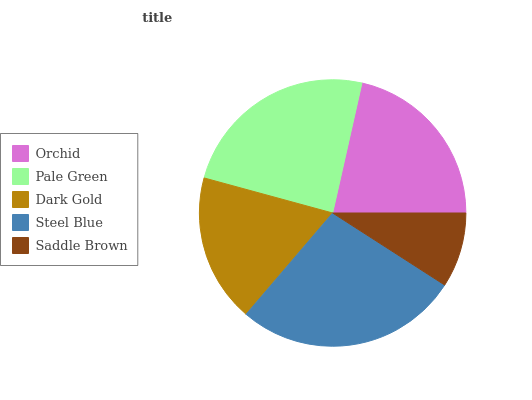Is Saddle Brown the minimum?
Answer yes or no. Yes. Is Steel Blue the maximum?
Answer yes or no. Yes. Is Pale Green the minimum?
Answer yes or no. No. Is Pale Green the maximum?
Answer yes or no. No. Is Pale Green greater than Orchid?
Answer yes or no. Yes. Is Orchid less than Pale Green?
Answer yes or no. Yes. Is Orchid greater than Pale Green?
Answer yes or no. No. Is Pale Green less than Orchid?
Answer yes or no. No. Is Orchid the high median?
Answer yes or no. Yes. Is Orchid the low median?
Answer yes or no. Yes. Is Saddle Brown the high median?
Answer yes or no. No. Is Steel Blue the low median?
Answer yes or no. No. 